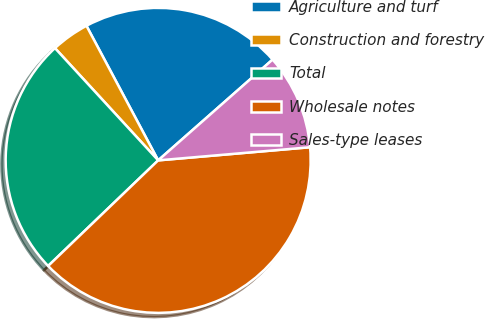Convert chart to OTSL. <chart><loc_0><loc_0><loc_500><loc_500><pie_chart><fcel>Agriculture and turf<fcel>Construction and forestry<fcel>Total<fcel>Wholesale notes<fcel>Sales-type leases<nl><fcel>21.3%<fcel>4.04%<fcel>25.34%<fcel>39.2%<fcel>10.12%<nl></chart> 